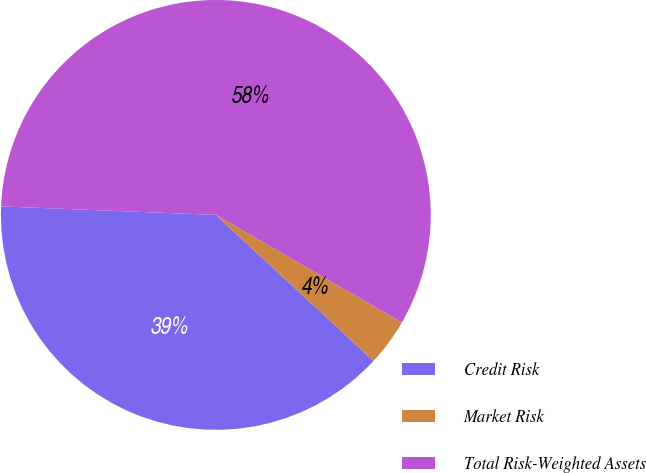Convert chart to OTSL. <chart><loc_0><loc_0><loc_500><loc_500><pie_chart><fcel>Credit Risk<fcel>Market Risk<fcel>Total Risk-Weighted Assets<nl><fcel>38.74%<fcel>3.55%<fcel>57.71%<nl></chart> 